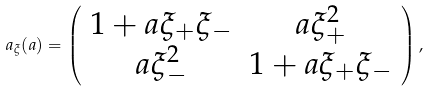Convert formula to latex. <formula><loc_0><loc_0><loc_500><loc_500>a _ { \xi } ( a ) = \left ( \begin{array} { c c } 1 + a \xi _ { + } \xi _ { - } & a \xi _ { + } ^ { 2 } \\ a \xi _ { - } ^ { 2 } & 1 + a \xi _ { + } \xi _ { - } \end{array} \right ) ,</formula> 